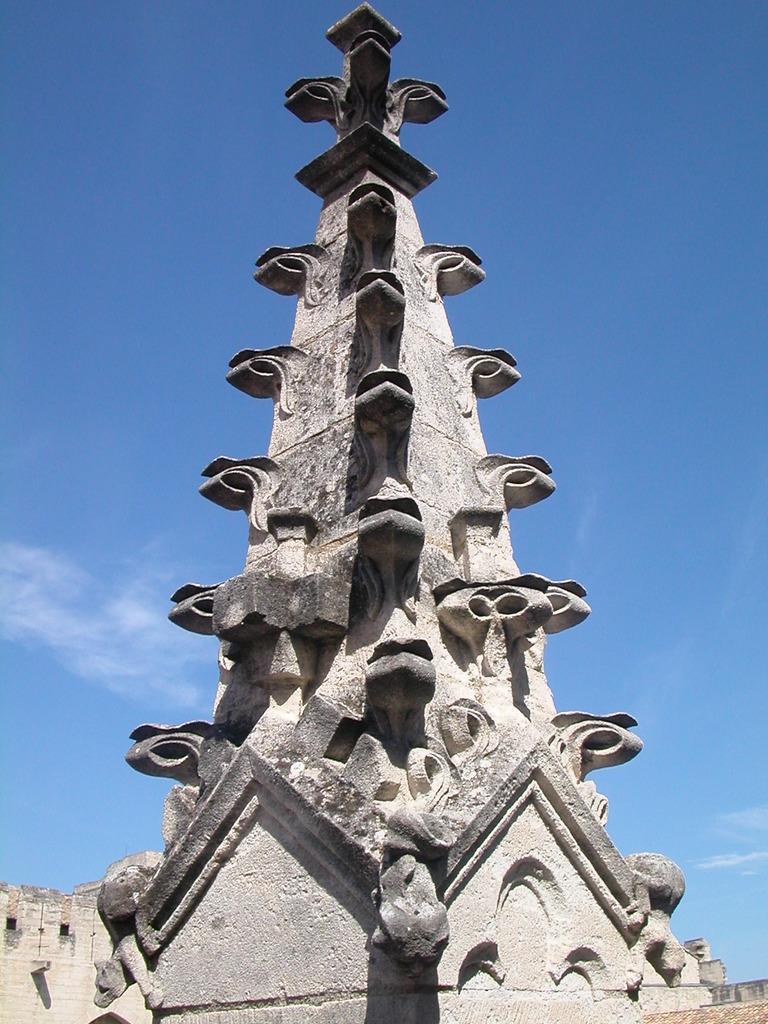How would you summarize this image in a sentence or two? In this image, this looks like an architectural pillar, which is built with the stones. This is the sky. 